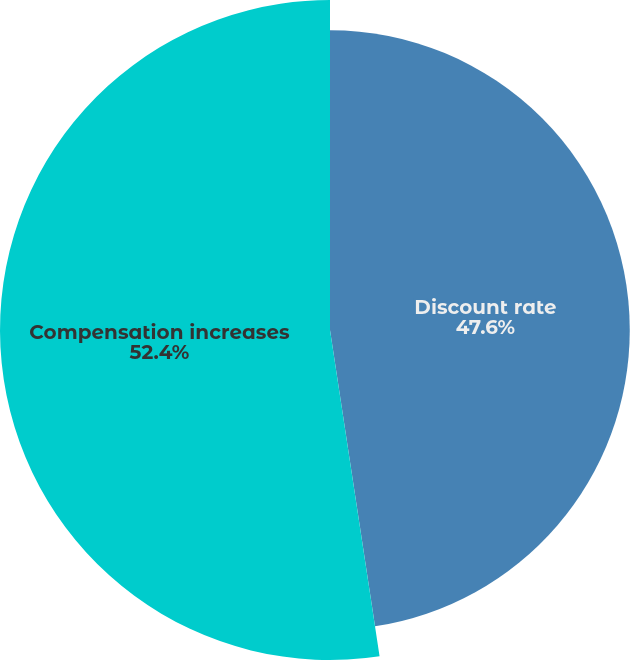Convert chart to OTSL. <chart><loc_0><loc_0><loc_500><loc_500><pie_chart><fcel>Discount rate<fcel>Compensation increases<nl><fcel>47.6%<fcel>52.4%<nl></chart> 